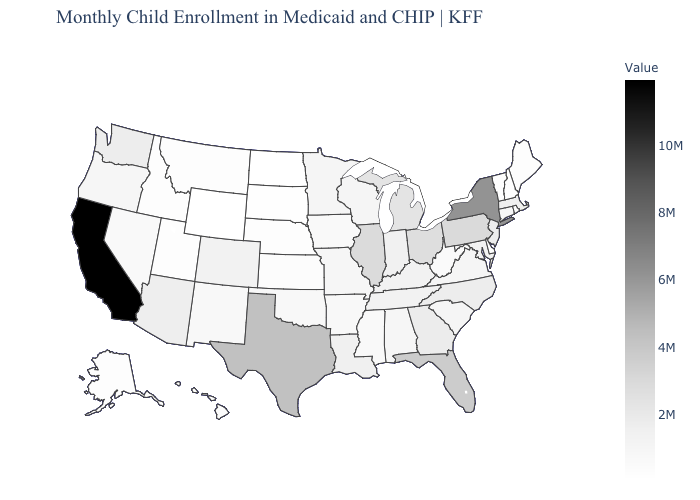Among the states that border Oregon , which have the highest value?
Give a very brief answer. California. Among the states that border Wisconsin , does Illinois have the highest value?
Be succinct. Yes. Does the map have missing data?
Write a very short answer. No. Among the states that border South Dakota , does Montana have the highest value?
Keep it brief. No. Among the states that border Vermont , which have the highest value?
Short answer required. New York. Does California have the highest value in the USA?
Short answer required. Yes. 